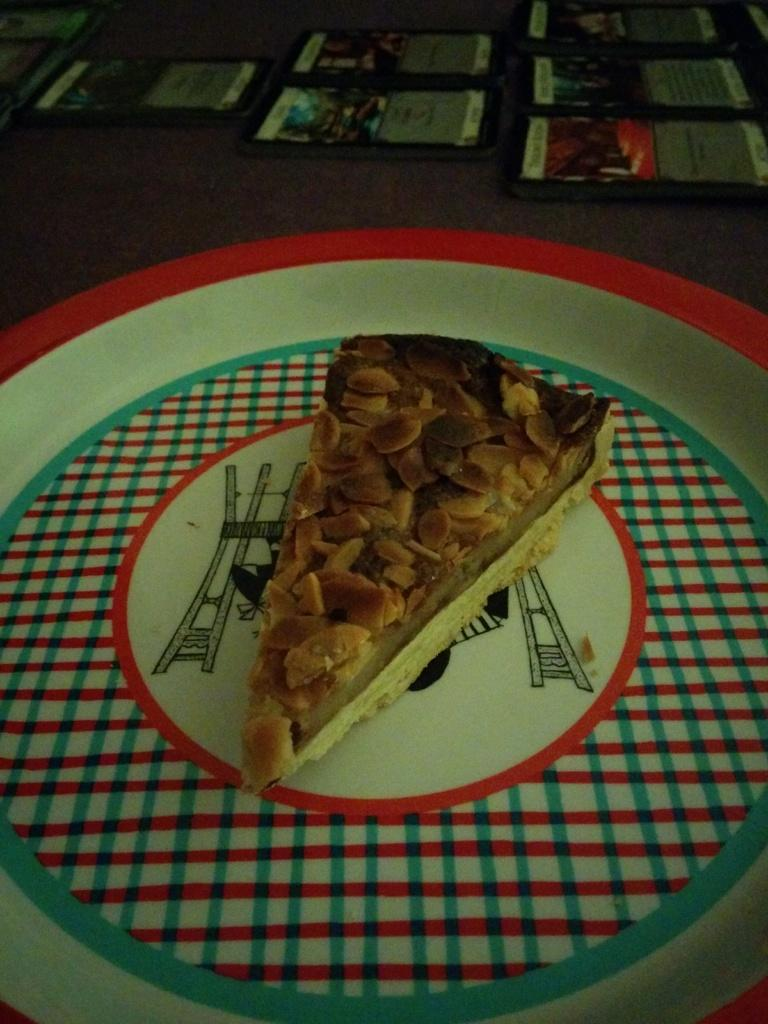What object can be seen in the image that is used for holding items? There is a tray in the image that is used for holding items. What type of items can be seen on the tray? Food items are present on the tray. What additional items are visible in the image? There are pamphlets visible at the top of the image. What type of advertisement can be seen in the sky in the image? There is no advertisement visible in the sky in the image. 